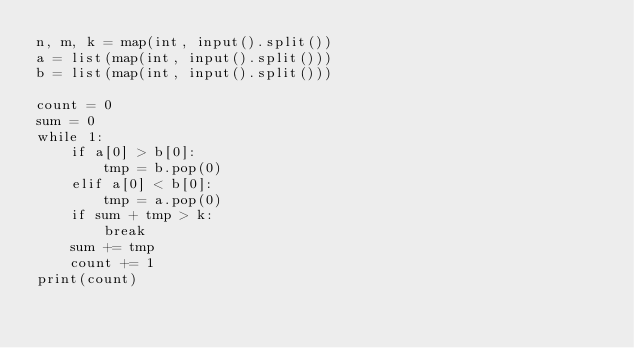<code> <loc_0><loc_0><loc_500><loc_500><_Python_>n, m, k = map(int, input().split())
a = list(map(int, input().split()))
b = list(map(int, input().split()))

count = 0
sum = 0
while 1:
    if a[0] > b[0]:
        tmp = b.pop(0)
    elif a[0] < b[0]:
        tmp = a.pop(0)
    if sum + tmp > k:
        break
    sum += tmp
    count += 1
print(count)</code> 